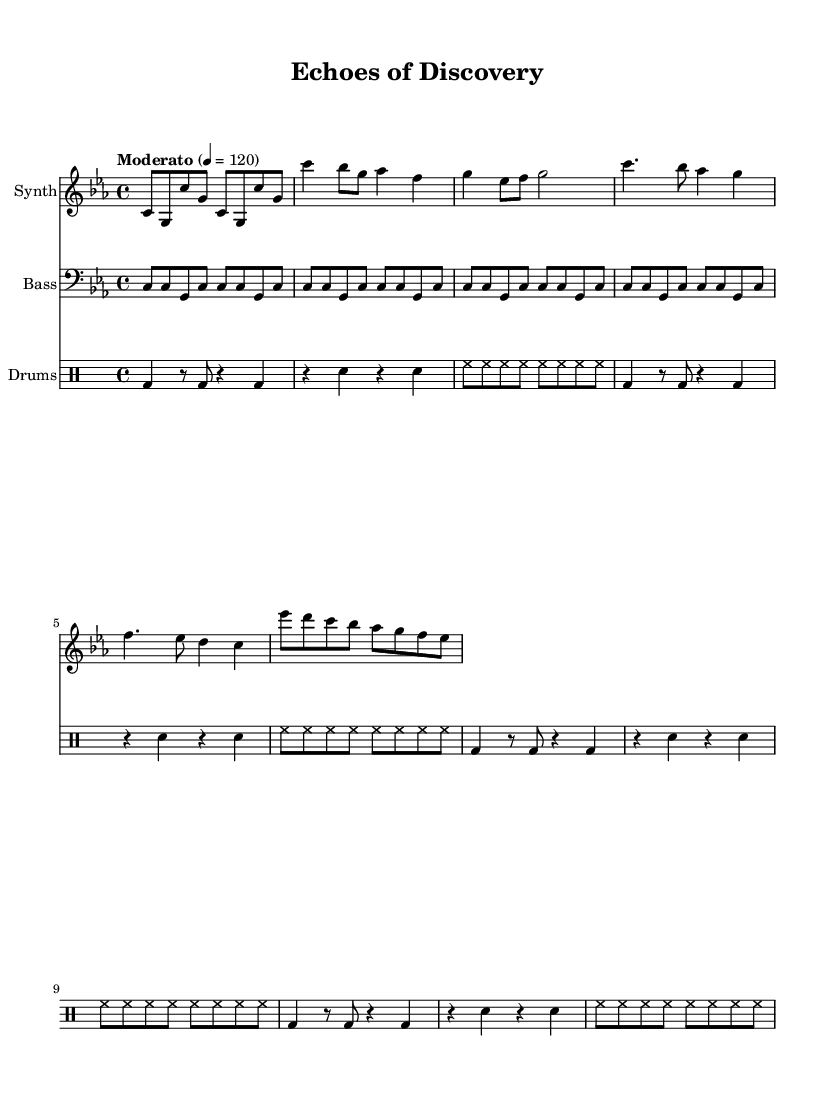What is the key signature of this music? The key signature shows three flat symbols that indicate the presence of B flat, E flat, and A flat notes, which places it in C minor.
Answer: C minor What is the time signature of this music? The time signature is indicated at the beginning of the score as 4/4, meaning there are four beats in each measure and the quarter note gets one beat.
Answer: 4/4 What is the tempo marking of this piece? The tempo marking is specified in the score as "Moderato" with a metronome marking of 120, indicating a moderate speed of playback.
Answer: Moderato How many measures are in the synthesizer part? By counting the measures in the synthesizer staff, there are 9 distinct measures indicated by the horizontal lines separating notes.
Answer: 9 What is the instrument labeled in the bass staff? The staff header of the bass part indicates that the instrument being played is the "Bass".
Answer: Bass What rhythmic pattern is featured in the drum section? The drum part includes a repeated pattern that comprises bass drum hits, snare hits, and hi-hat notes which gives it a structured rhythmic framework for the piece.
Answer: Alternating bass and snare with hi-hat on eighth notes What type of electronic sounds are represented in the synthesizer part? The synthesizer part showcases melodic lines that mimic experimental laboratory sounds, suggesting an integration of electronic elements typical in electronic music.
Answer: Laboratory sounds 